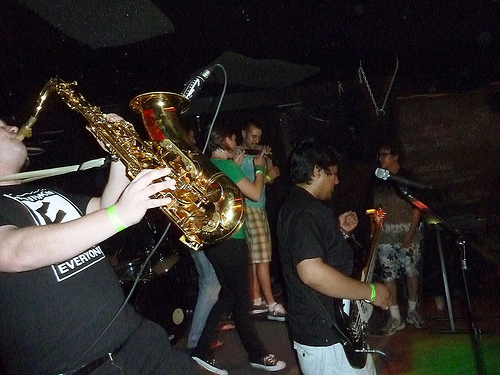<image>
Is there a microphone on the saxophone? Yes. Looking at the image, I can see the microphone is positioned on top of the saxophone, with the saxophone providing support. 